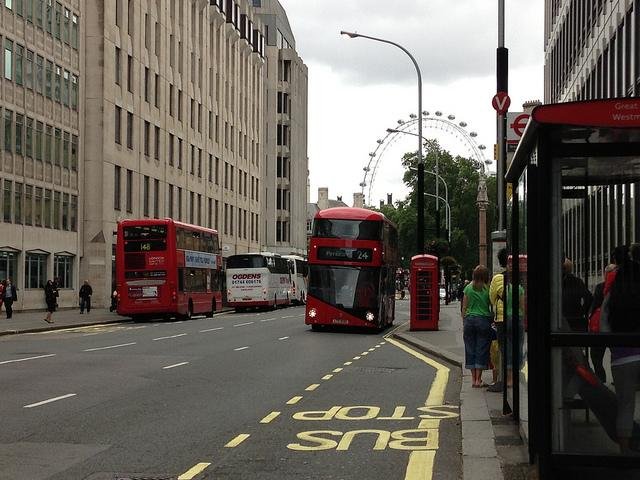What company owns vehicles similar to the ones in the street?

Choices:
A) tesla
B) dunkin donuts
C) mcdonalds
D) greyhound greyhound 